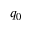<formula> <loc_0><loc_0><loc_500><loc_500>q _ { 0 }</formula> 